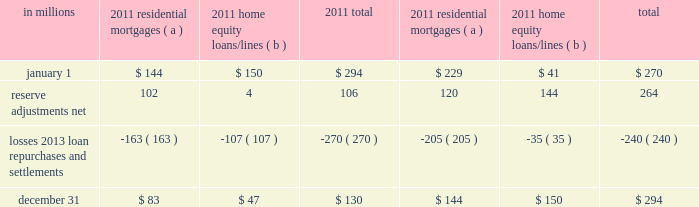Agreements associated with the agency securitizations , most sale agreements do not provide for penalties or other remedies if we do not respond timely to investor indemnification or repurchase requests .
Origination and sale of residential mortgages is an ongoing business activity and , accordingly , management continually assesses the need to recognize indemnification and repurchase liabilities pursuant to the associated investor sale agreements .
We establish indemnification and repurchase liabilities for estimated losses on sold first and second-lien mortgages and home equity loans/lines for which indemnification is expected to be provided or for loans that are expected to be repurchased .
For the first and second-lien mortgage sold portfolio , we have established an indemnification and repurchase liability pursuant to investor sale agreements based on claims made and our estimate of future claims on a loan by loan basis .
These relate primarily to loans originated during 2006-2008 .
For the home equity loans/lines sold portfolio , we have established indemnification and repurchase liabilities based upon this same methodology for loans sold during 2005-2007 .
Indemnification and repurchase liabilities are initially recognized when loans are sold to investors and are subsequently evaluated by management .
Initial recognition and subsequent adjustments to the indemnification and repurchase liability for the sold residential mortgage portfolio are recognized in residential mortgage revenue on the consolidated income statement .
Since pnc is no longer engaged in the brokered home equity lending business , only subsequent adjustments are recognized to the home equity loans/lines indemnification and repurchase liability .
These adjustments are recognized in other noninterest income on the consolidated income statement .
Management 2019s subsequent evaluation of these indemnification and repurchase liabilities is based upon trends in indemnification and repurchase requests , actual loss experience , risks in the underlying serviced loan portfolios , and current economic conditions .
As part of its evaluation , management considers estimated loss projections over the life of the subject loan portfolio .
At december 31 , 2011 and december 31 , 2010 , the total indemnification and repurchase liability for estimated losses on indemnification and repurchase claims totaled $ 130 million and $ 294 million , respectively , and was included in other liabilities on the consolidated balance sheet .
An analysis of the changes in this liability during 2011 and 2010 follows : analysis of indemnification and repurchase liability for asserted claims and unasserted claims .
( a ) repurchase obligation associated with sold loan portfolios of $ 121.4 billion and $ 139.8 billion at december 31 , 2011 and december 31 , 2010 , respectively .
( b ) repurchase obligation associated with sold loan portfolios of $ 4.5 billion and $ 6.5 billion at december 31 , 2011 and december 31 , 2010 , respectively .
Pnc is no longer engaged in the brokered home equity lending business , which was acquired with national city .
Management believes our indemnification and repurchase liabilities appropriately reflect the estimated probable losses on investor indemnification and repurchase claims at december 31 , 2011 and 2010 .
While management seeks to obtain all relevant information in estimating the indemnification and repurchase liability , the estimation process is inherently uncertain and imprecise and , accordingly , it is reasonably possible that future indemnification and repurchase losses could be more or less than our established liability .
Factors that could affect our estimate include the volume of valid claims driven by investor strategies and behavior , our ability to successfully negotiate claims with investors , housing prices , and other economic conditions .
At december 31 , 2011 , we estimate that it is reasonably possible that we could incur additional losses in excess of our indemnification and repurchase liability of up to $ 85 million .
This estimate of potential additional losses in excess of our liability is based on assumed higher investor demands , lower claim rescissions , and lower home prices than our current assumptions .
Reinsurance agreements we have two wholly-owned captive insurance subsidiaries which provide reinsurance to third-party insurers related to insurance sold to our customers .
These subsidiaries enter into various types of reinsurance agreements with third-party insurers where the subsidiary assumes the risk of loss through either an excess of loss or quota share agreement up to 100% ( 100 % ) reinsurance .
In excess of loss agreements , these subsidiaries assume the risk of loss for an excess layer of coverage up to specified limits , once a defined first loss percentage is met .
In quota share agreements , the subsidiaries and third-party insurers share the responsibility for payment of all claims .
These subsidiaries provide reinsurance for accidental death & dismemberment , credit life , accident & health , lender placed 200 the pnc financial services group , inc .
2013 form 10-k .
Residential mortgages were what percent of the total indemnification and repurchase liability for asserted claims and unasserted claims as of december 31 2011? 
Computations: (83 / 130)
Answer: 0.63846. 